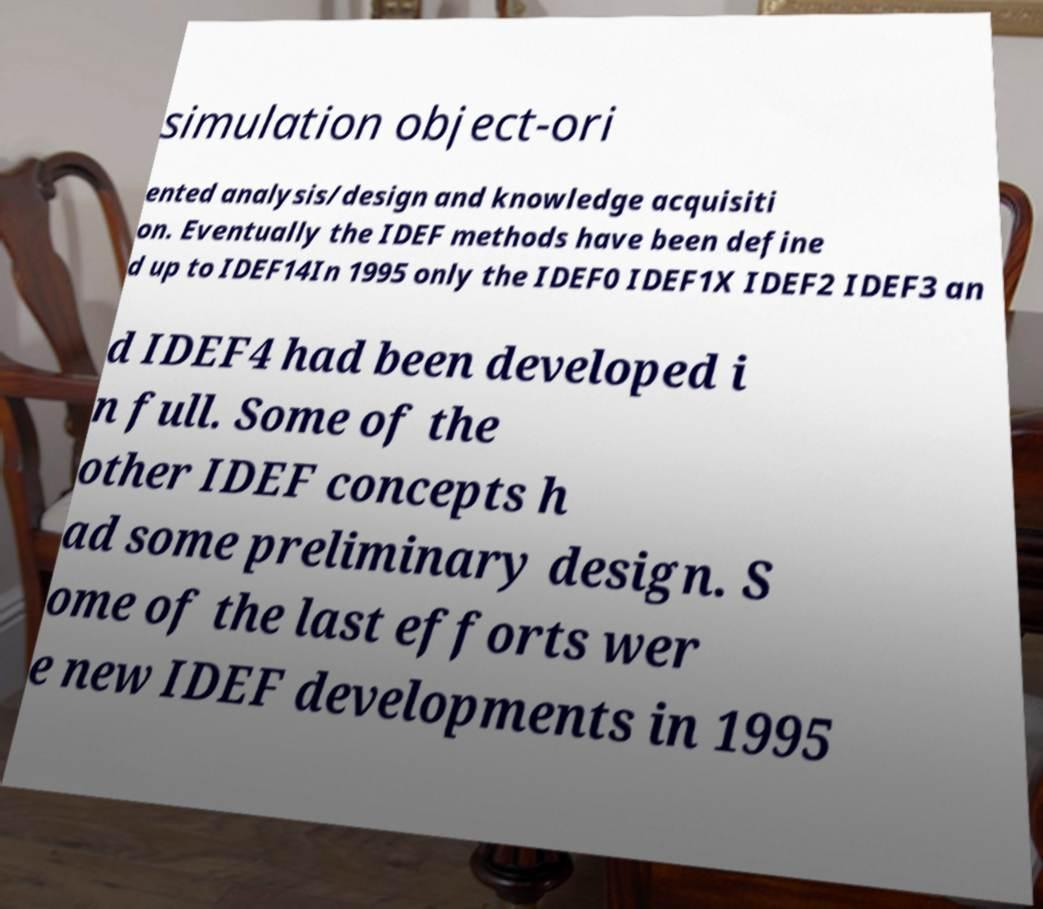Please read and relay the text visible in this image. What does it say? simulation object-ori ented analysis/design and knowledge acquisiti on. Eventually the IDEF methods have been define d up to IDEF14In 1995 only the IDEF0 IDEF1X IDEF2 IDEF3 an d IDEF4 had been developed i n full. Some of the other IDEF concepts h ad some preliminary design. S ome of the last efforts wer e new IDEF developments in 1995 